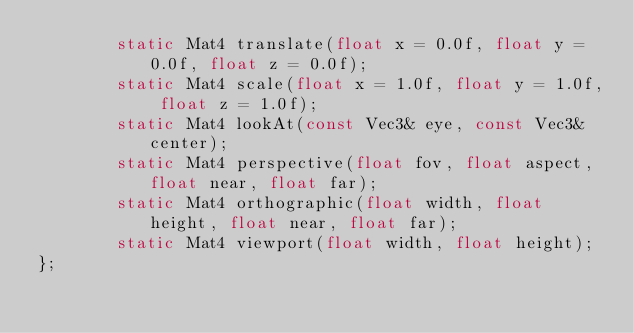<code> <loc_0><loc_0><loc_500><loc_500><_C_>		static Mat4 translate(float x = 0.0f, float y = 0.0f, float z = 0.0f);
		static Mat4 scale(float x = 1.0f, float y = 1.0f, float z = 1.0f);
		static Mat4 lookAt(const Vec3& eye, const Vec3& center);
		static Mat4 perspective(float fov, float aspect, float near, float far);
		static Mat4 orthographic(float width, float height, float near, float far);
		static Mat4 viewport(float width, float height);
};
</code> 